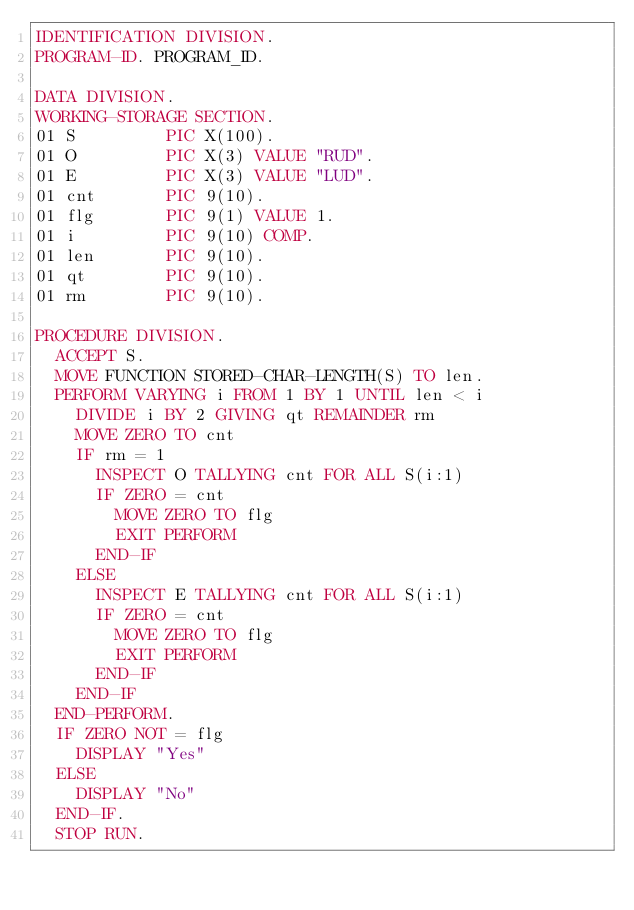<code> <loc_0><loc_0><loc_500><loc_500><_COBOL_>IDENTIFICATION DIVISION.
PROGRAM-ID. PROGRAM_ID.

DATA DIVISION.
WORKING-STORAGE SECTION.
01 S         PIC X(100).
01 O         PIC X(3) VALUE "RUD".
01 E         PIC X(3) VALUE "LUD".
01 cnt       PIC 9(10).
01 flg       PIC 9(1) VALUE 1.
01 i         PIC 9(10) COMP.
01 len       PIC 9(10).
01 qt        PIC 9(10).
01 rm        PIC 9(10).

PROCEDURE DIVISION.
  ACCEPT S.
  MOVE FUNCTION STORED-CHAR-LENGTH(S) TO len.
  PERFORM VARYING i FROM 1 BY 1 UNTIL len < i
    DIVIDE i BY 2 GIVING qt REMAINDER rm
    MOVE ZERO TO cnt
    IF rm = 1
      INSPECT O TALLYING cnt FOR ALL S(i:1)
      IF ZERO = cnt
        MOVE ZERO TO flg
        EXIT PERFORM
      END-IF
    ELSE
      INSPECT E TALLYING cnt FOR ALL S(i:1)
      IF ZERO = cnt
        MOVE ZERO TO flg
        EXIT PERFORM
      END-IF
    END-IF
  END-PERFORM.
  IF ZERO NOT = flg
    DISPLAY "Yes"
  ELSE
    DISPLAY "No"
  END-IF.
  STOP RUN.
</code> 